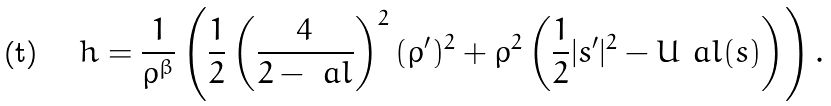<formula> <loc_0><loc_0><loc_500><loc_500>h = \frac { 1 } { \rho ^ { \beta } } \left ( \frac { 1 } { 2 } \left ( \frac { 4 } { 2 - \ a l } \right ) ^ { 2 } ( \rho ^ { \prime } ) ^ { 2 } + \rho ^ { 2 } \left ( \frac { 1 } { 2 } | s ^ { \prime } | ^ { 2 } - U _ { \ } a l ( s ) \right ) \right ) .</formula> 